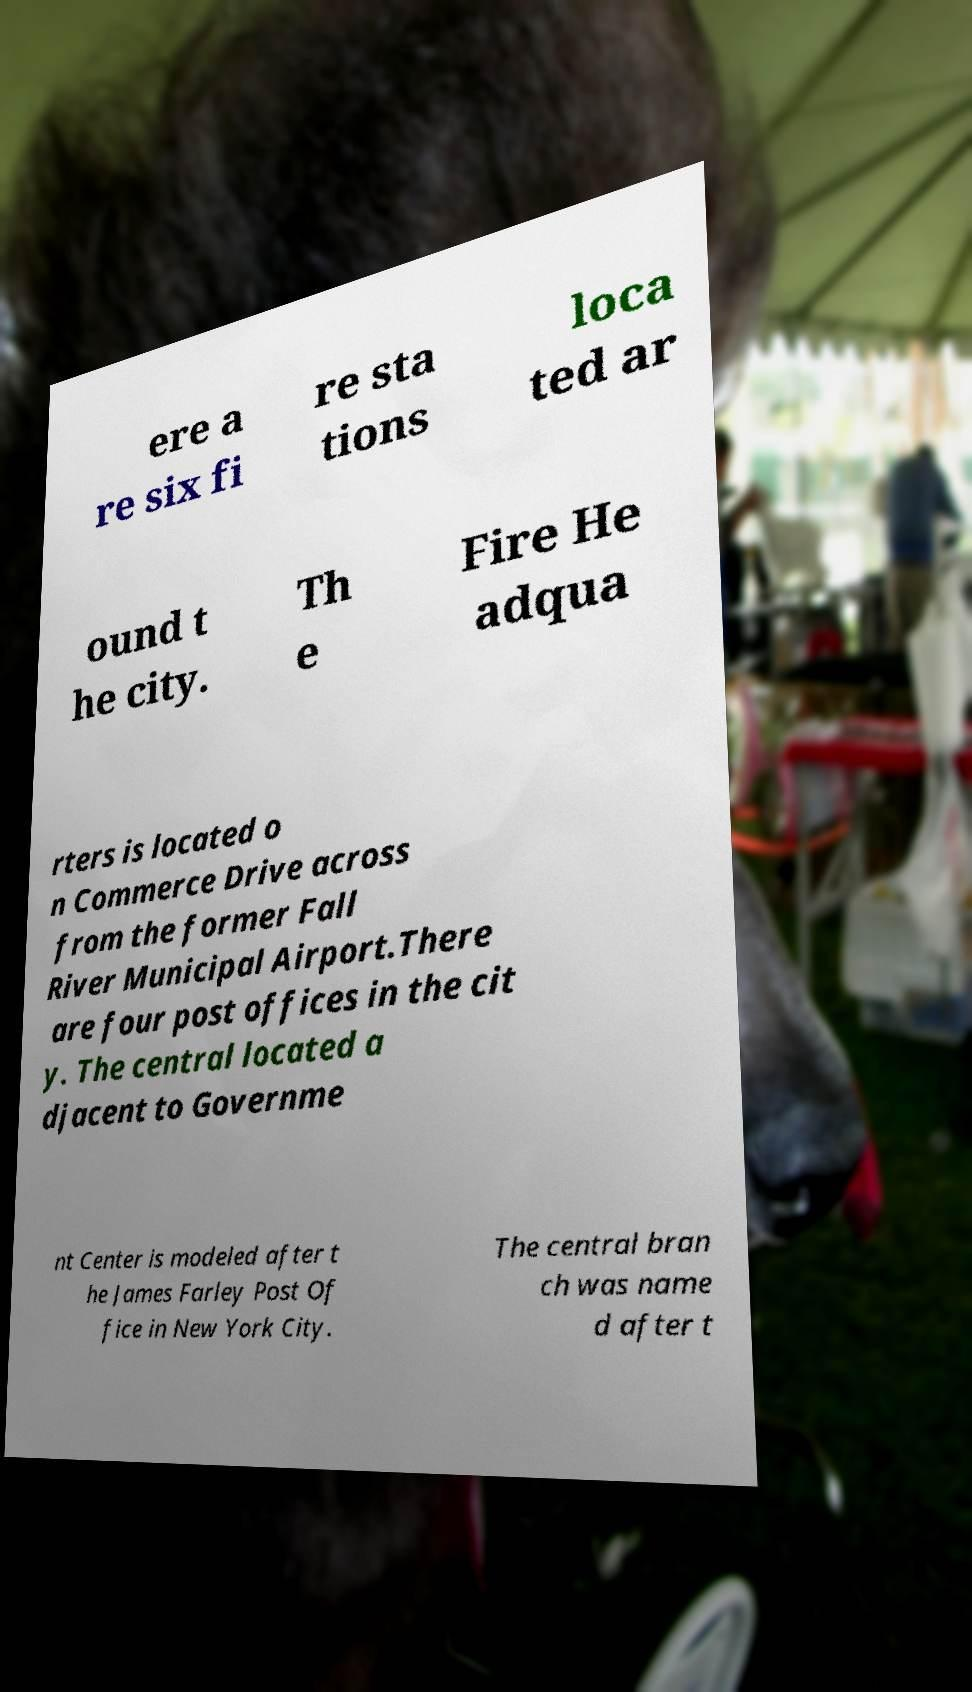Please identify and transcribe the text found in this image. ere a re six fi re sta tions loca ted ar ound t he city. Th e Fire He adqua rters is located o n Commerce Drive across from the former Fall River Municipal Airport.There are four post offices in the cit y. The central located a djacent to Governme nt Center is modeled after t he James Farley Post Of fice in New York City. The central bran ch was name d after t 